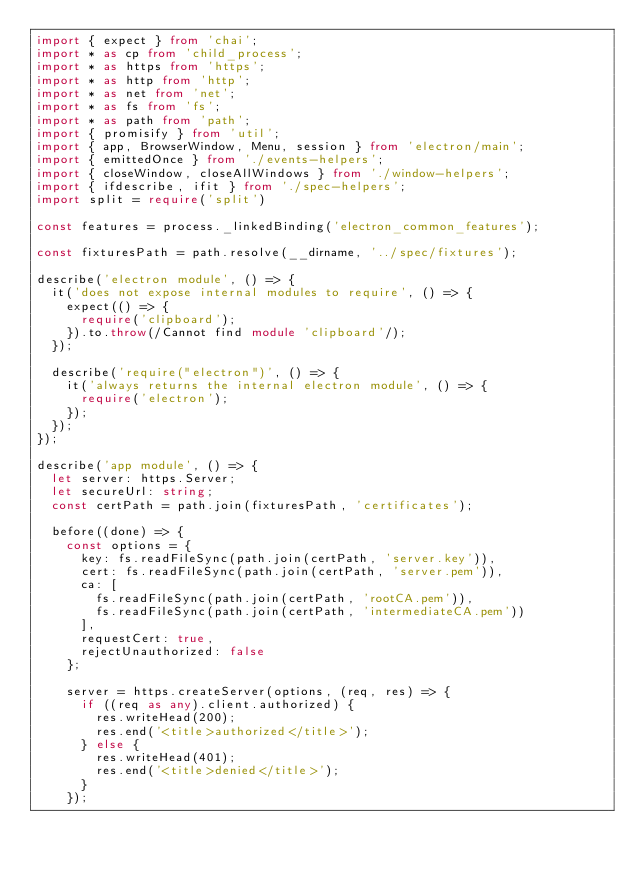<code> <loc_0><loc_0><loc_500><loc_500><_TypeScript_>import { expect } from 'chai';
import * as cp from 'child_process';
import * as https from 'https';
import * as http from 'http';
import * as net from 'net';
import * as fs from 'fs';
import * as path from 'path';
import { promisify } from 'util';
import { app, BrowserWindow, Menu, session } from 'electron/main';
import { emittedOnce } from './events-helpers';
import { closeWindow, closeAllWindows } from './window-helpers';
import { ifdescribe, ifit } from './spec-helpers';
import split = require('split')

const features = process._linkedBinding('electron_common_features');

const fixturesPath = path.resolve(__dirname, '../spec/fixtures');

describe('electron module', () => {
  it('does not expose internal modules to require', () => {
    expect(() => {
      require('clipboard');
    }).to.throw(/Cannot find module 'clipboard'/);
  });

  describe('require("electron")', () => {
    it('always returns the internal electron module', () => {
      require('electron');
    });
  });
});

describe('app module', () => {
  let server: https.Server;
  let secureUrl: string;
  const certPath = path.join(fixturesPath, 'certificates');

  before((done) => {
    const options = {
      key: fs.readFileSync(path.join(certPath, 'server.key')),
      cert: fs.readFileSync(path.join(certPath, 'server.pem')),
      ca: [
        fs.readFileSync(path.join(certPath, 'rootCA.pem')),
        fs.readFileSync(path.join(certPath, 'intermediateCA.pem'))
      ],
      requestCert: true,
      rejectUnauthorized: false
    };

    server = https.createServer(options, (req, res) => {
      if ((req as any).client.authorized) {
        res.writeHead(200);
        res.end('<title>authorized</title>');
      } else {
        res.writeHead(401);
        res.end('<title>denied</title>');
      }
    });
</code> 